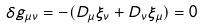<formula> <loc_0><loc_0><loc_500><loc_500>\delta g _ { \mu \nu } = - ( D _ { \mu } \xi _ { \nu } + D _ { \nu } \xi _ { \mu } ) = 0</formula> 